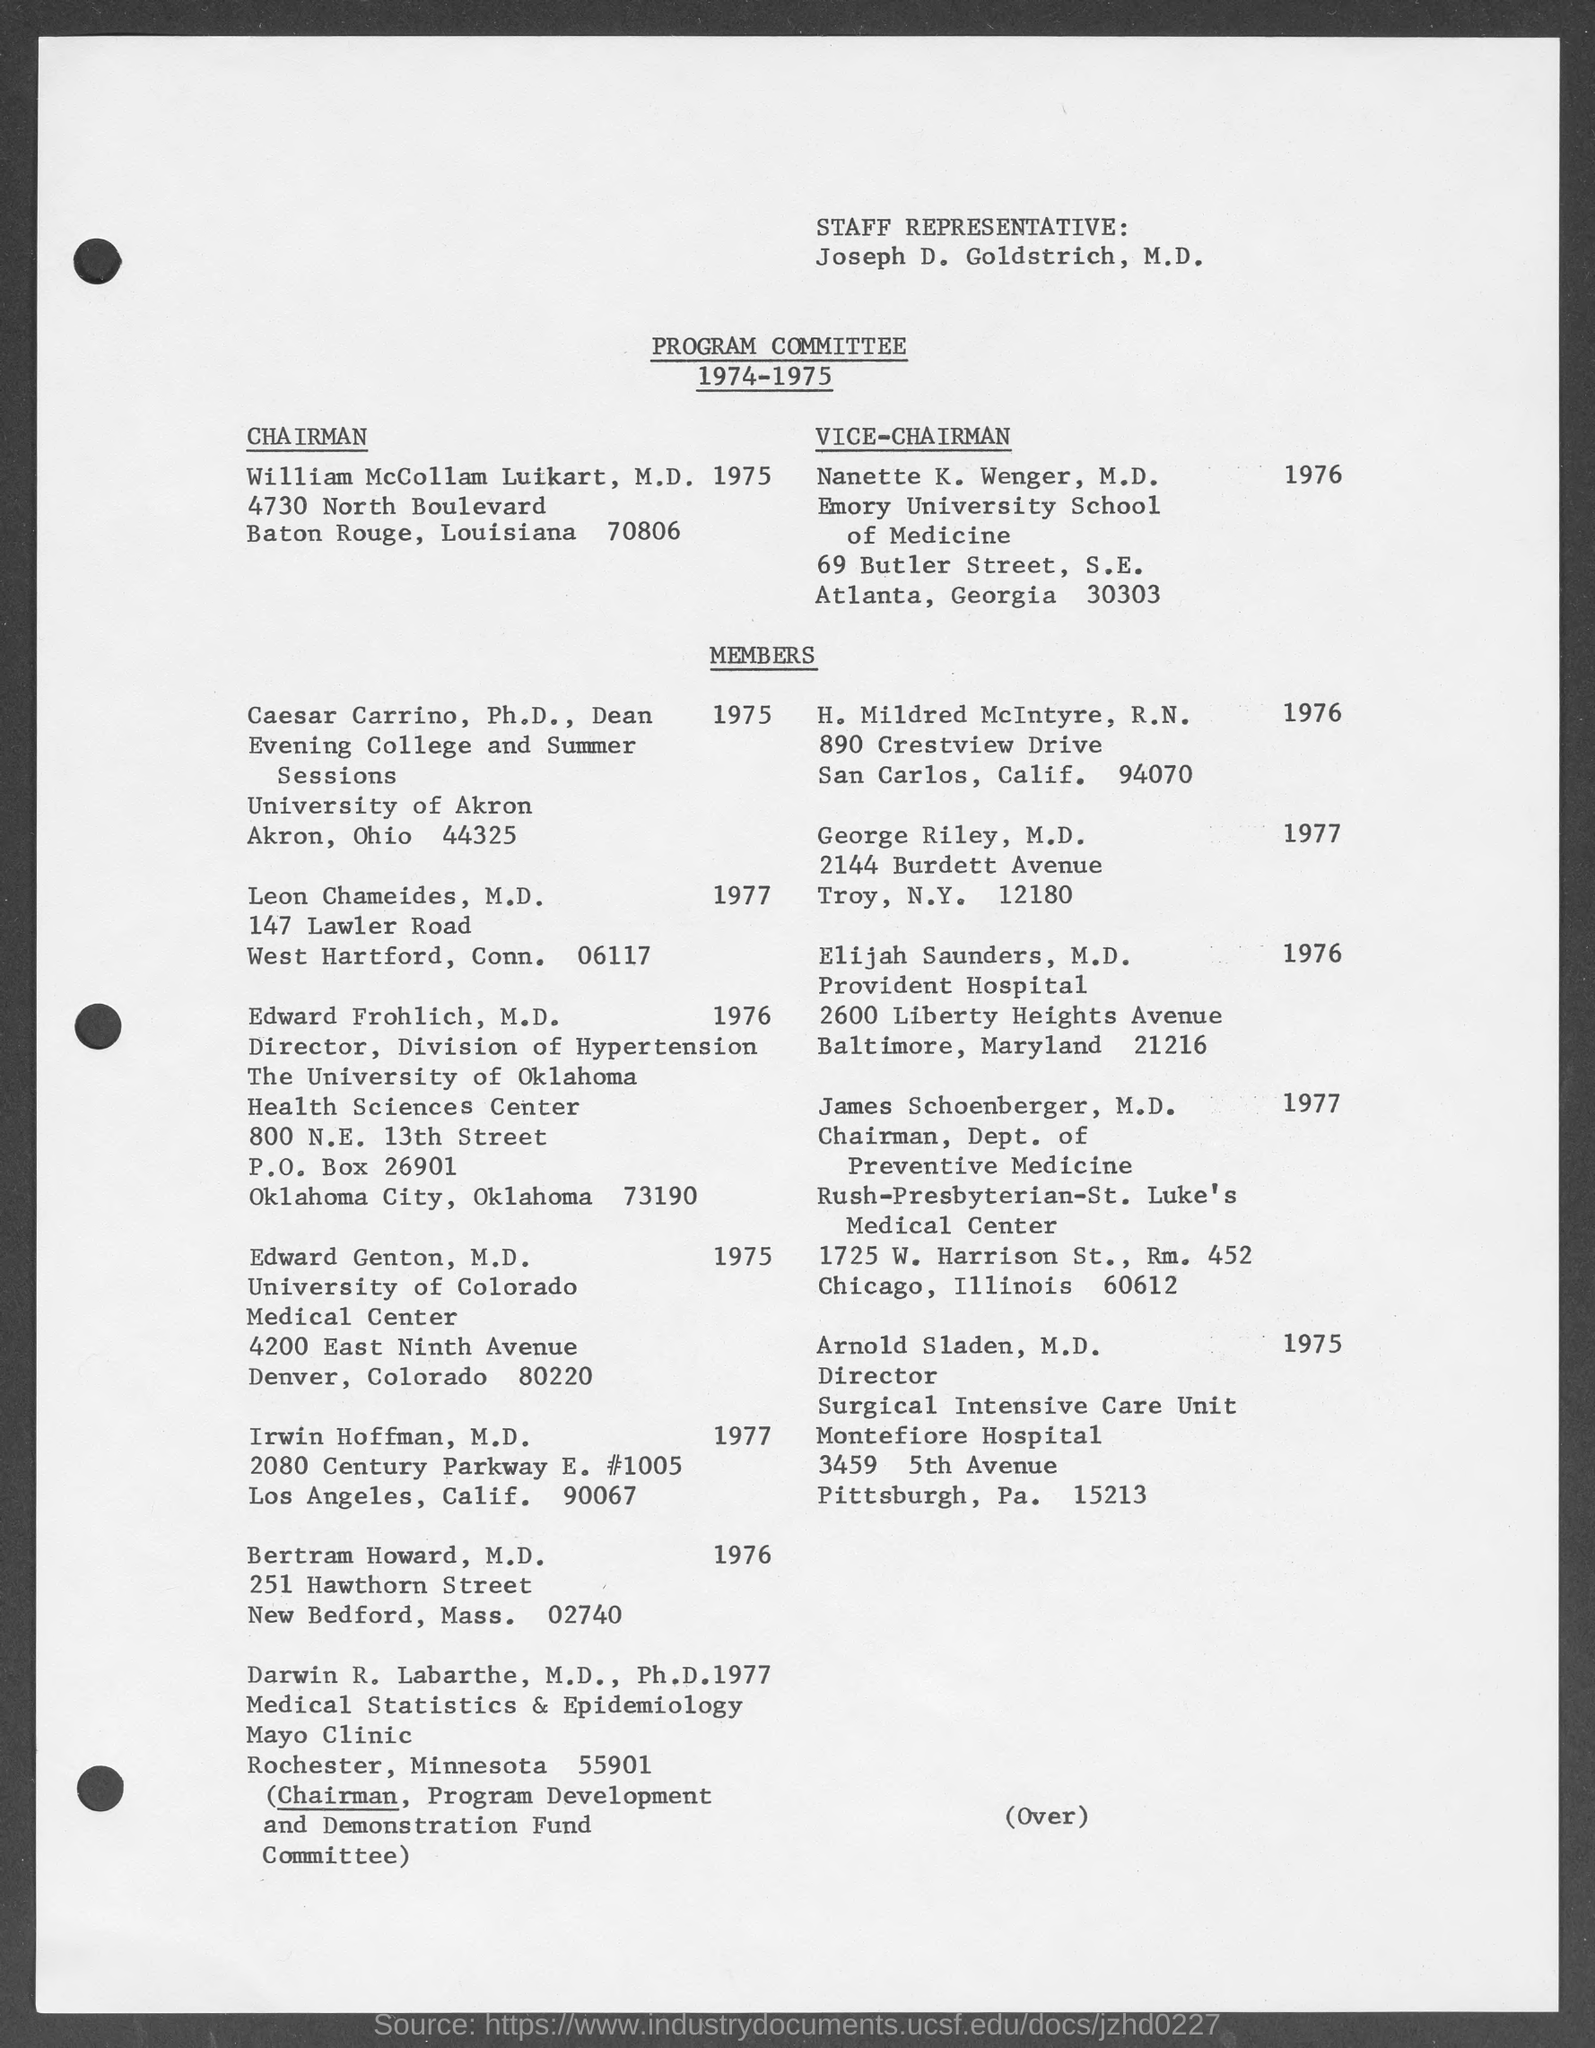Identify some key points in this picture. Edward Frohlich is a student at the University of Oklahoma. Edward Genton belongs to the University of Colorado. Caesar Carrino belongs to the University of Akron. Nanette K. Wenger is affiliated with Emory University School of Medicine. 